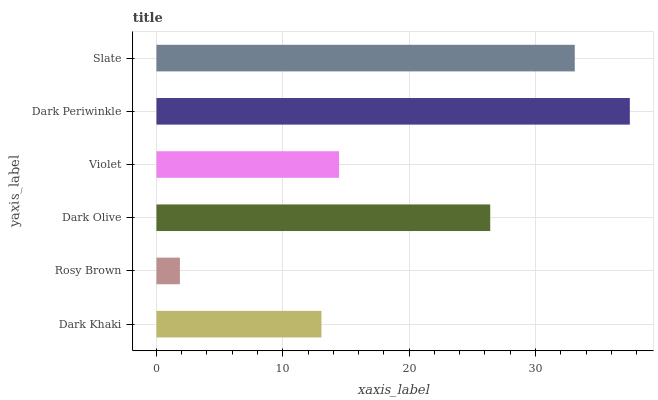Is Rosy Brown the minimum?
Answer yes or no. Yes. Is Dark Periwinkle the maximum?
Answer yes or no. Yes. Is Dark Olive the minimum?
Answer yes or no. No. Is Dark Olive the maximum?
Answer yes or no. No. Is Dark Olive greater than Rosy Brown?
Answer yes or no. Yes. Is Rosy Brown less than Dark Olive?
Answer yes or no. Yes. Is Rosy Brown greater than Dark Olive?
Answer yes or no. No. Is Dark Olive less than Rosy Brown?
Answer yes or no. No. Is Dark Olive the high median?
Answer yes or no. Yes. Is Violet the low median?
Answer yes or no. Yes. Is Dark Periwinkle the high median?
Answer yes or no. No. Is Dark Khaki the low median?
Answer yes or no. No. 